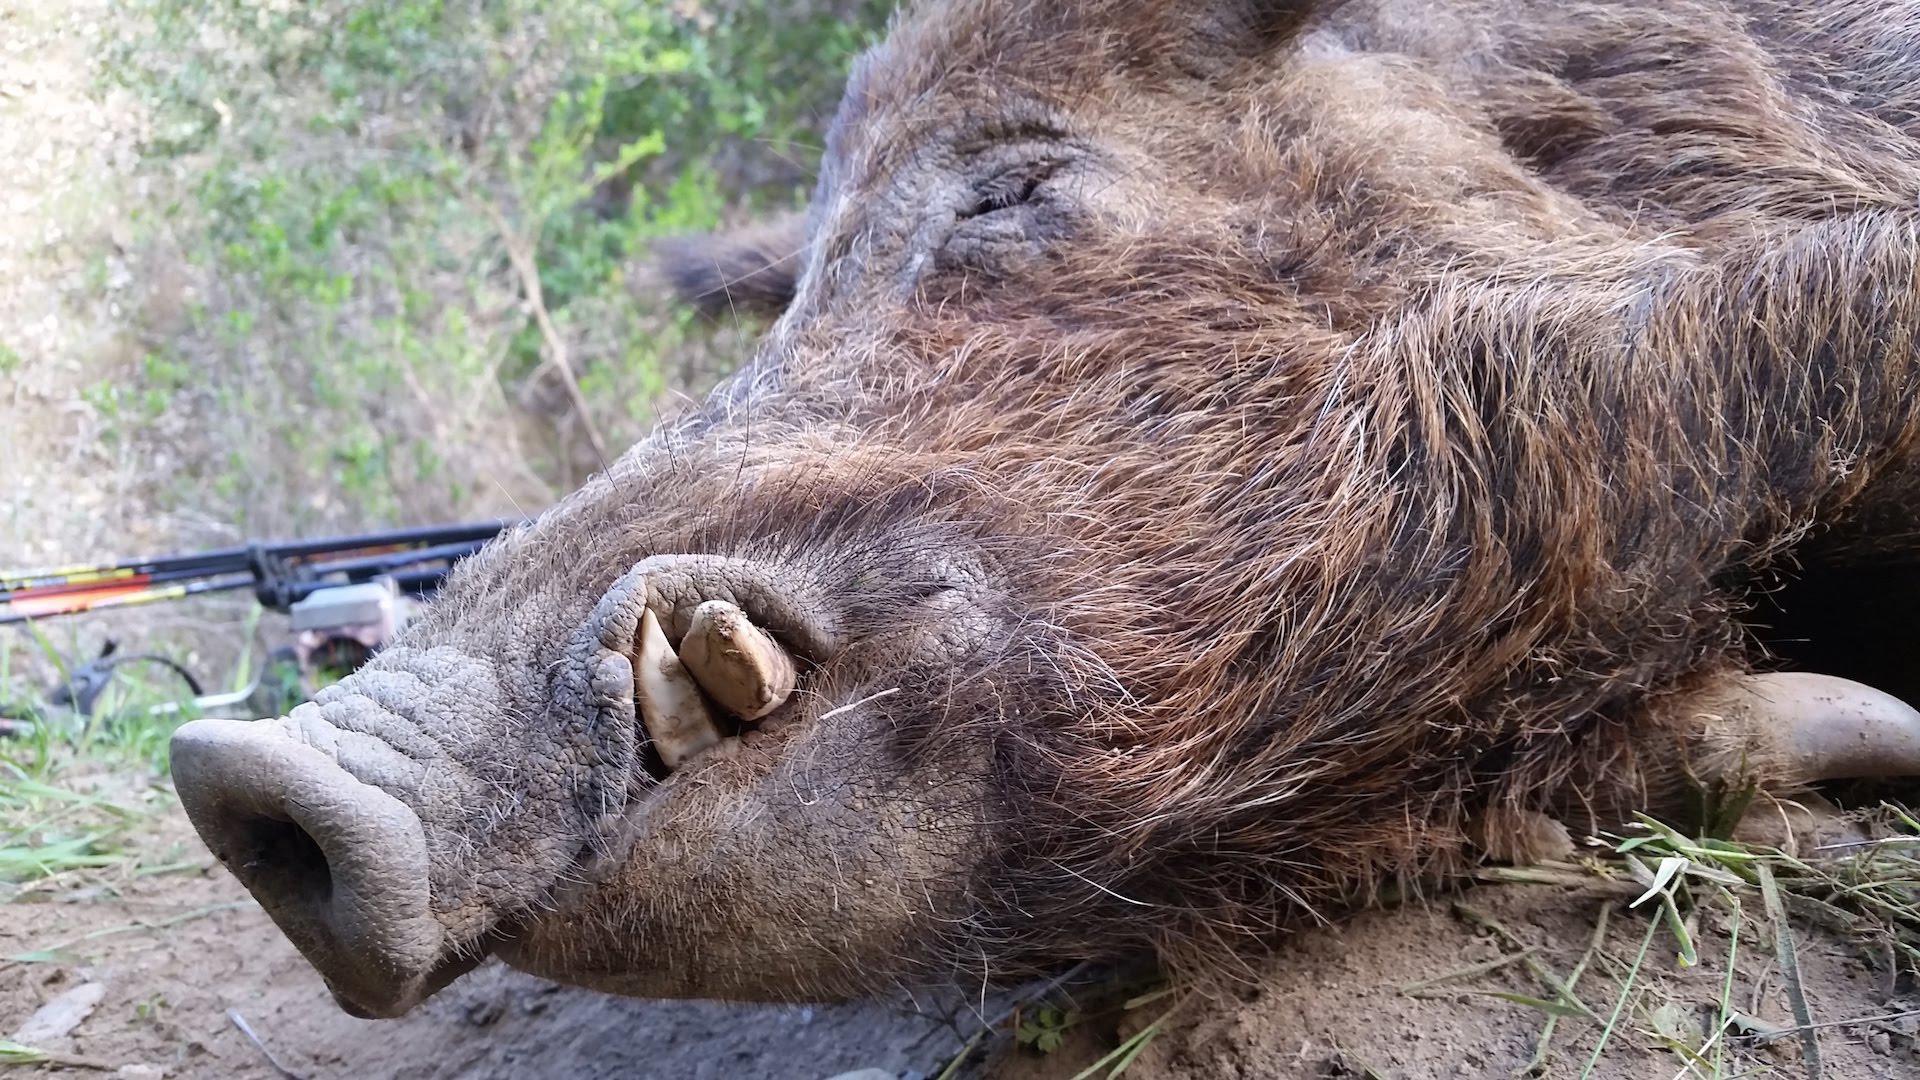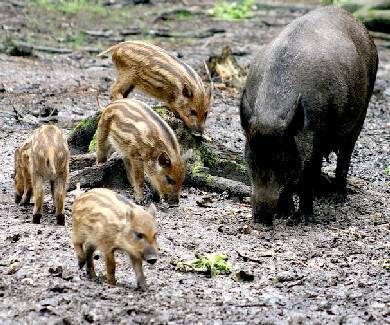The first image is the image on the left, the second image is the image on the right. Assess this claim about the two images: "A mother warhog is rooting with her nose to the ground with her piglets near her". Correct or not? Answer yes or no. Yes. The first image is the image on the left, the second image is the image on the right. For the images shown, is this caption "In the right image, there's a wild boar with her piglets." true? Answer yes or no. Yes. 